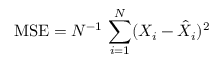<formula> <loc_0><loc_0><loc_500><loc_500>M S E = N ^ { - 1 } \, \sum _ { i = 1 } ^ { N } ( X _ { i } - \hat { X } _ { i } ) ^ { 2 }</formula> 